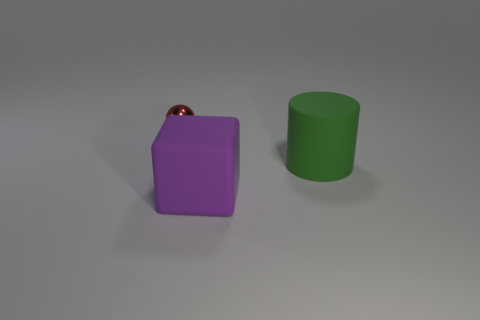There is a large matte object behind the big object that is left of the large rubber thing that is behind the big purple rubber object; what is its shape?
Make the answer very short. Cylinder. What number of red metallic things have the same size as the metallic ball?
Keep it short and to the point. 0. Is there a large green cylinder that is to the left of the object behind the green object?
Make the answer very short. No. What number of objects are either large green matte cylinders or small cyan rubber cylinders?
Your answer should be compact. 1. There is a large matte thing that is in front of the big object that is behind the big object that is in front of the big cylinder; what is its color?
Offer a very short reply. Purple. Is there anything else that has the same color as the large matte block?
Provide a succinct answer. No. Do the green matte cylinder and the matte block have the same size?
Give a very brief answer. Yes. What number of things are either big rubber objects that are right of the large purple matte thing or objects that are left of the big green matte cylinder?
Your response must be concise. 3. What material is the thing that is to the left of the rubber object in front of the big green cylinder?
Provide a short and direct response. Metal. What number of other things are made of the same material as the cube?
Offer a terse response. 1. 